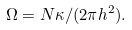<formula> <loc_0><loc_0><loc_500><loc_500>\Omega = N \kappa / ( 2 \pi h ^ { 2 } ) .</formula> 